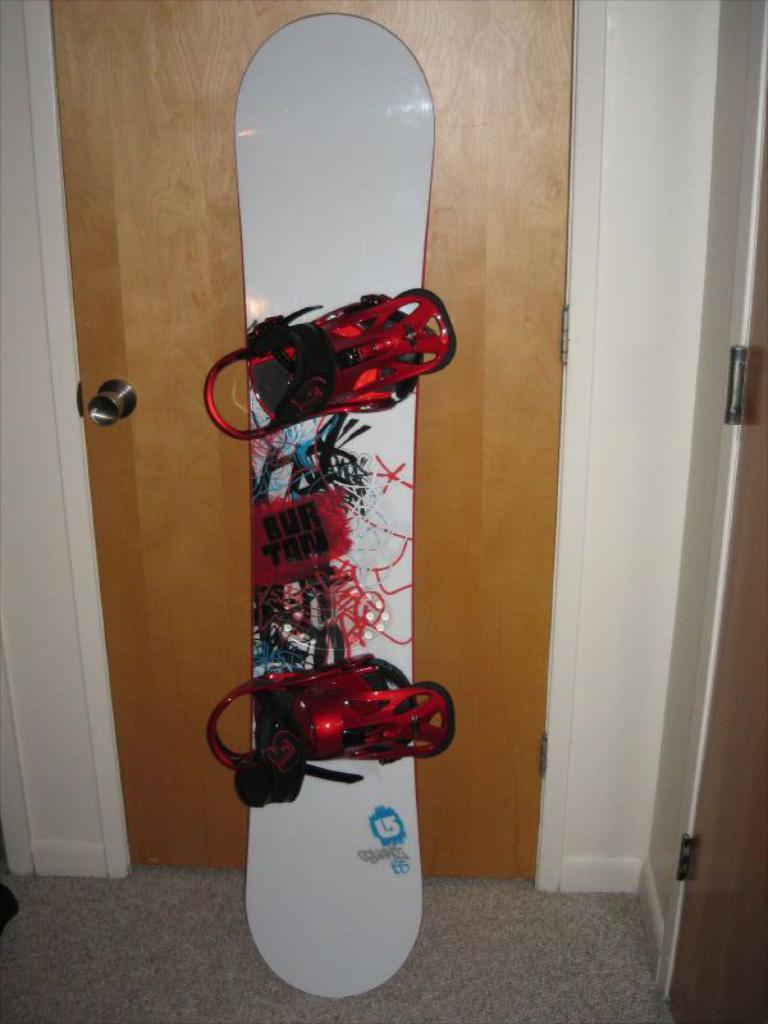What object is on the floor in the image? There is a skateboard on the floor. What type of structure is present in the image? There is a door and a wall in the image. What type of bait is being used to catch fish in the image? There is no mention of fish or bait in the image; it only features a skateboard, a door, and a wall. 